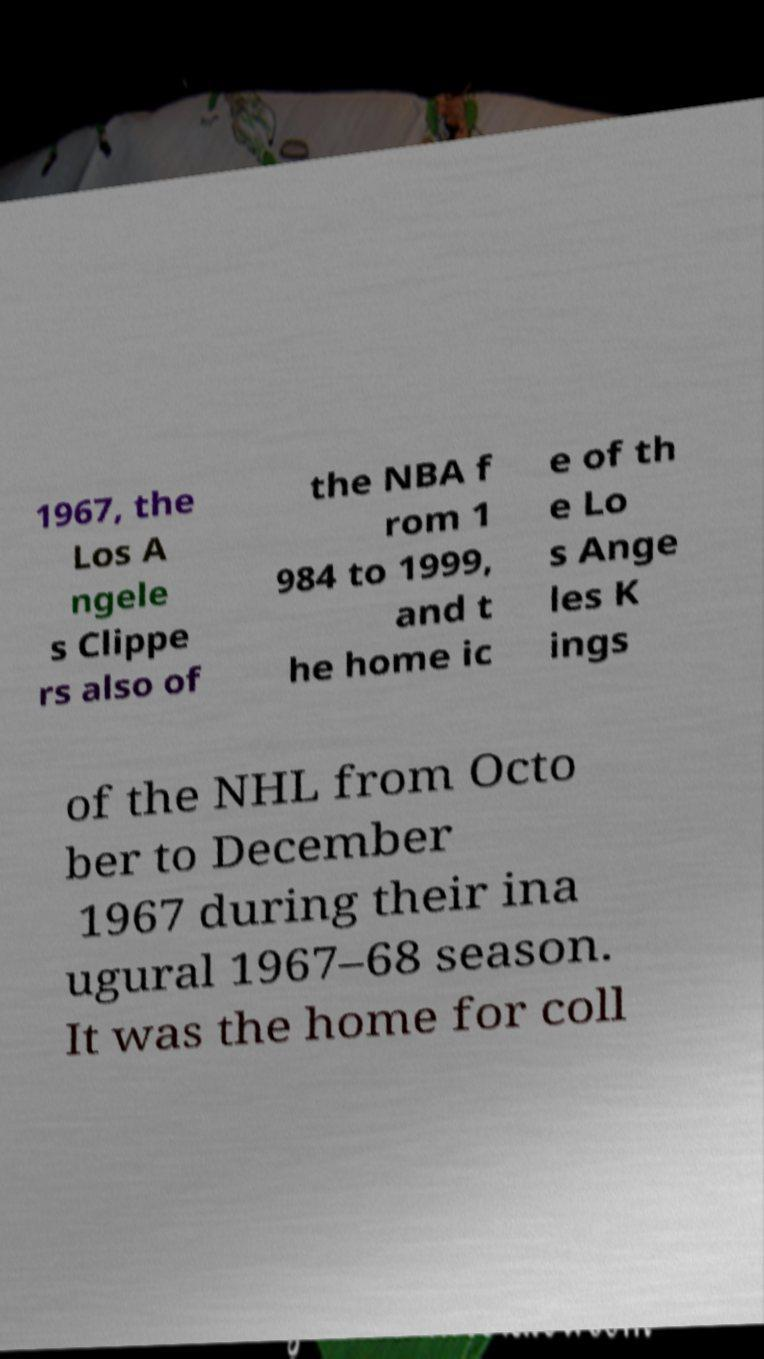There's text embedded in this image that I need extracted. Can you transcribe it verbatim? 1967, the Los A ngele s Clippe rs also of the NBA f rom 1 984 to 1999, and t he home ic e of th e Lo s Ange les K ings of the NHL from Octo ber to December 1967 during their ina ugural 1967–68 season. It was the home for coll 